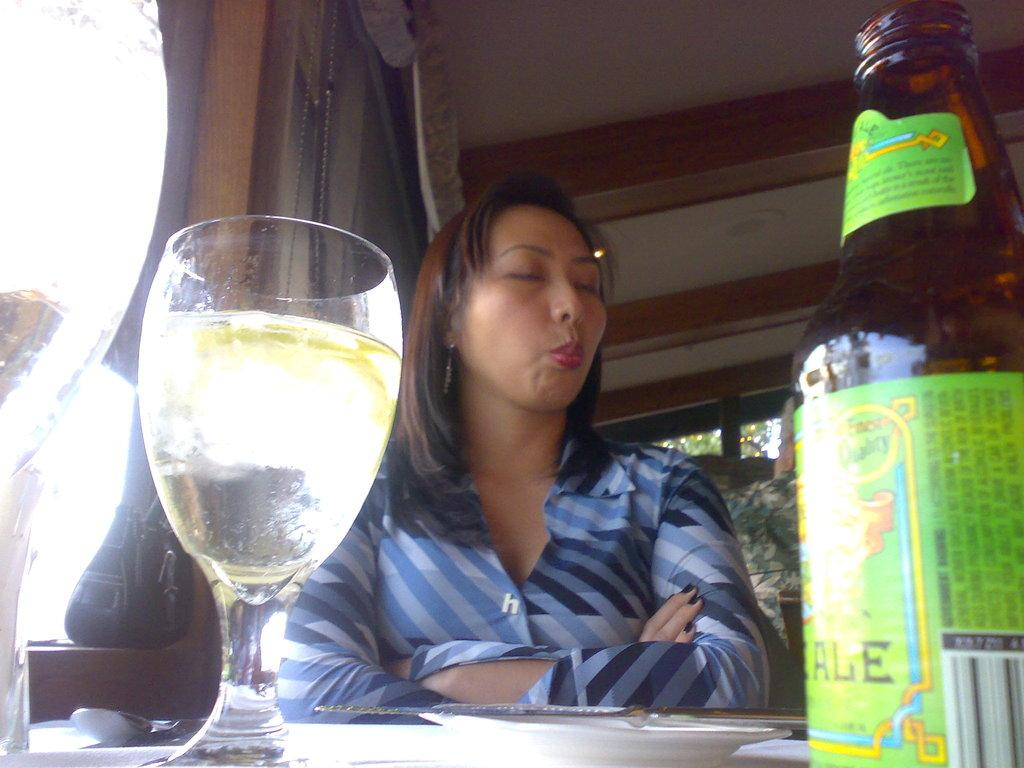What is the woman in the image doing? The woman is sitting in the image. What objects are in front of the woman? There is a bottle with a sticker and a glass with a drink in it in front of the woman. What can be seen in the background of the image? There is a window and a wall visible in the background of the image. What type of authority does the woman have in the image? There is no indication of the woman's authority in the image. Are there any icicles visible in the image? There are no icicles present in the image. 